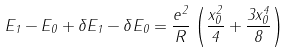Convert formula to latex. <formula><loc_0><loc_0><loc_500><loc_500>E _ { 1 } - E _ { 0 } + \delta E _ { 1 } - \delta E _ { 0 } = \frac { e ^ { 2 } } { R } \left ( \frac { x _ { 0 } ^ { 2 } } { 4 } + \frac { 3 x _ { 0 } ^ { 4 } } { 8 } \right )</formula> 